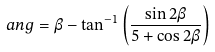<formula> <loc_0><loc_0><loc_500><loc_500>\ a n g = \beta - \tan ^ { - 1 } \left ( \frac { \sin 2 \beta } { 5 + \cos 2 \beta } \right )</formula> 